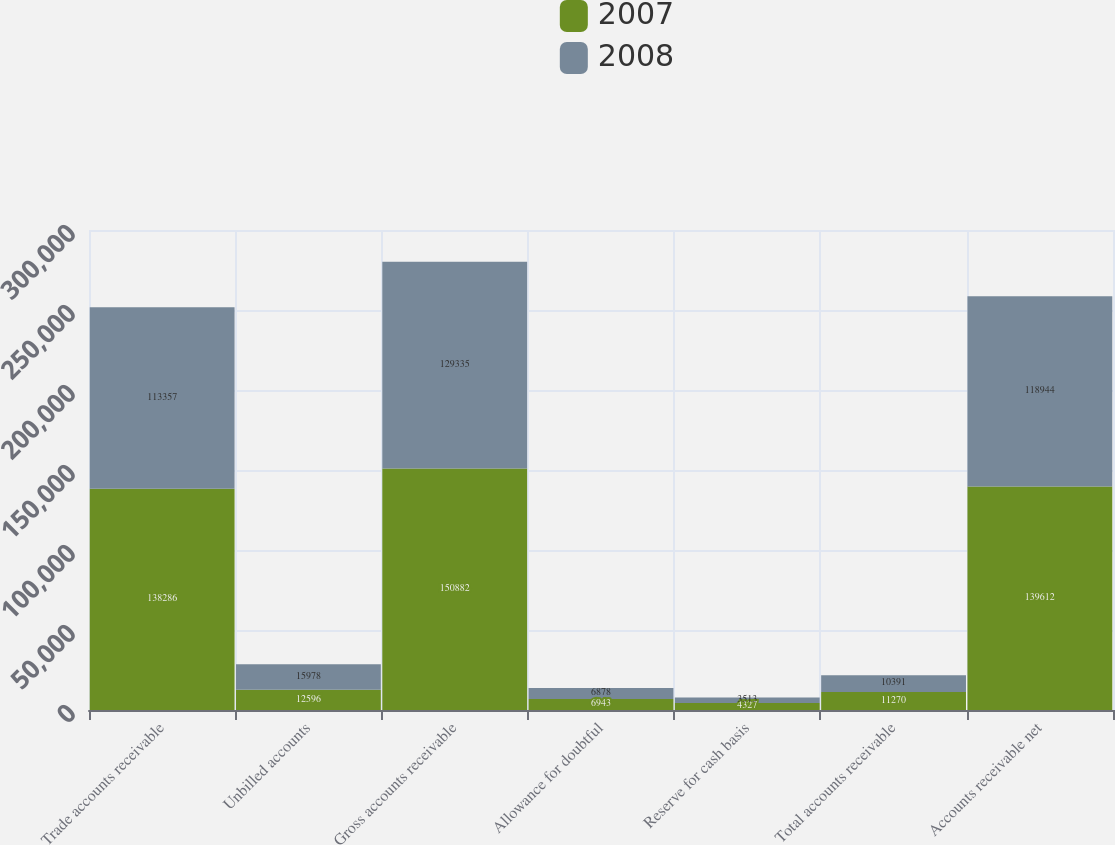Convert chart. <chart><loc_0><loc_0><loc_500><loc_500><stacked_bar_chart><ecel><fcel>Trade accounts receivable<fcel>Unbilled accounts<fcel>Gross accounts receivable<fcel>Allowance for doubtful<fcel>Reserve for cash basis<fcel>Total accounts receivable<fcel>Accounts receivable net<nl><fcel>2007<fcel>138286<fcel>12596<fcel>150882<fcel>6943<fcel>4327<fcel>11270<fcel>139612<nl><fcel>2008<fcel>113357<fcel>15978<fcel>129335<fcel>6878<fcel>3513<fcel>10391<fcel>118944<nl></chart> 